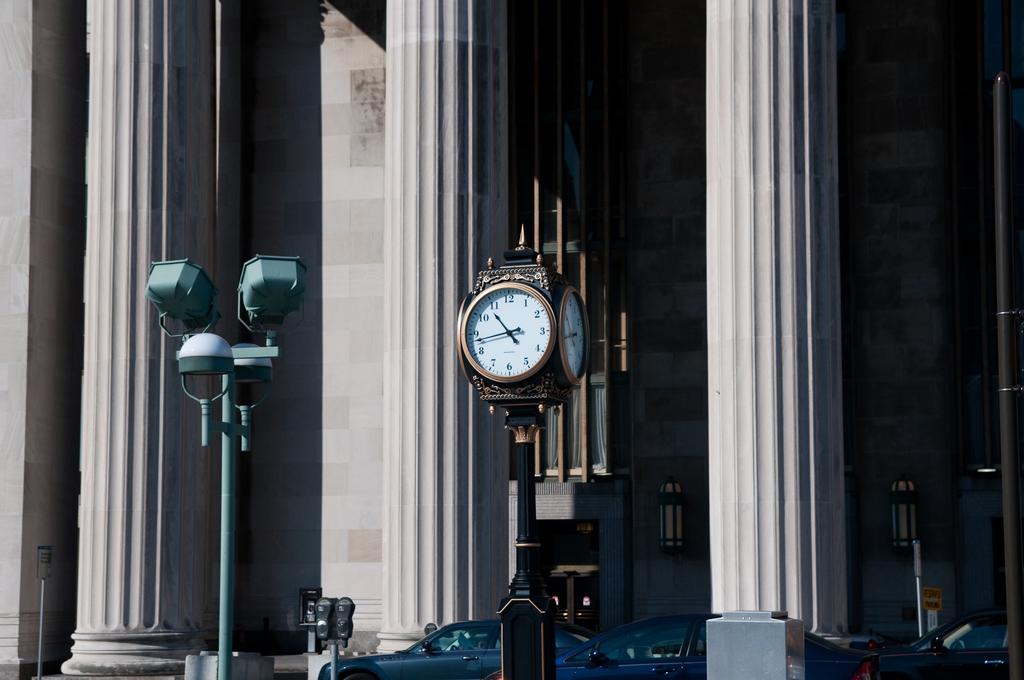What does the clock read?
Make the answer very short. 10:43. 